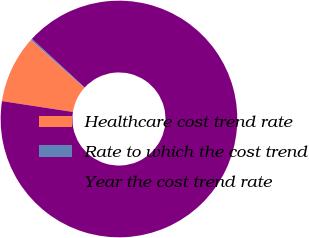Convert chart. <chart><loc_0><loc_0><loc_500><loc_500><pie_chart><fcel>Healthcare cost trend rate<fcel>Rate to which the cost trend<fcel>Year the cost trend rate<nl><fcel>9.23%<fcel>0.2%<fcel>90.57%<nl></chart> 